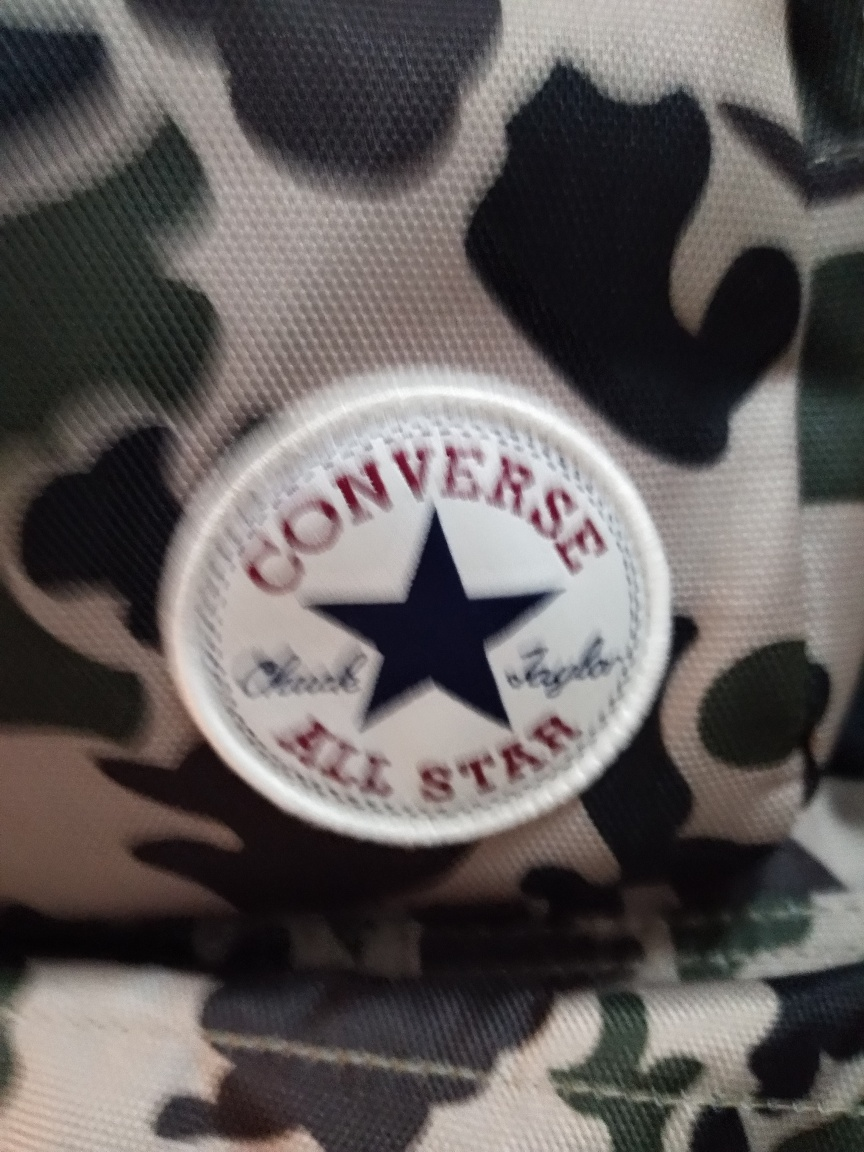Are there any quality issues with this image? Yes, the image appears to be slightly out of focus, and there's notable motion blur. These aspects diminish the overall sharpness and make the details less crisp. Additionally, the lighting seems to be uneven, with potential overexposure on the emblem, which could affect the visibility of finer details. It is also taken at an angle, instead of head-on, which might distort the perspective. 